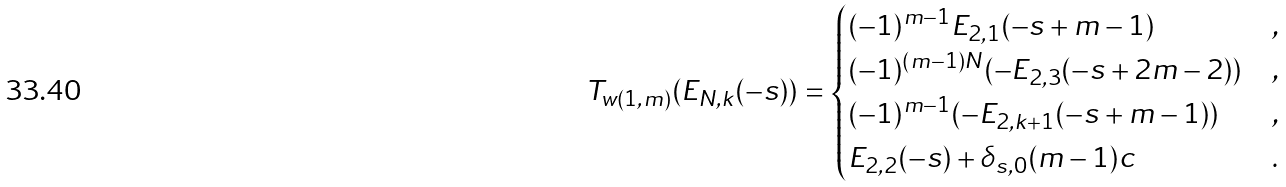Convert formula to latex. <formula><loc_0><loc_0><loc_500><loc_500>T _ { w ( 1 , m ) } ( E _ { N , k } ( - s ) ) = \begin{cases} ( - 1 ) ^ { m - 1 } E _ { 2 , 1 } ( - s + m - 1 ) & , \\ ( - 1 ) ^ { ( m - 1 ) N } ( - E _ { 2 , 3 } ( - s + 2 m - 2 ) ) & , \\ ( - 1 ) ^ { m - 1 } ( - E _ { 2 , k + 1 } ( - s + m - 1 ) ) & , \\ E _ { 2 , 2 } ( - s ) + \delta _ { s , 0 } ( m - 1 ) c & . \end{cases}</formula> 